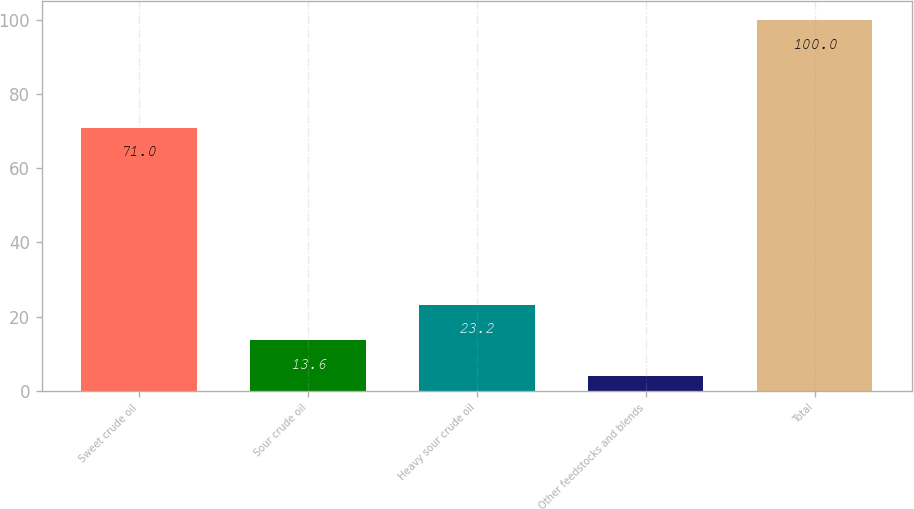Convert chart to OTSL. <chart><loc_0><loc_0><loc_500><loc_500><bar_chart><fcel>Sweet crude oil<fcel>Sour crude oil<fcel>Heavy sour crude oil<fcel>Other feedstocks and blends<fcel>Total<nl><fcel>71<fcel>13.6<fcel>23.2<fcel>4<fcel>100<nl></chart> 